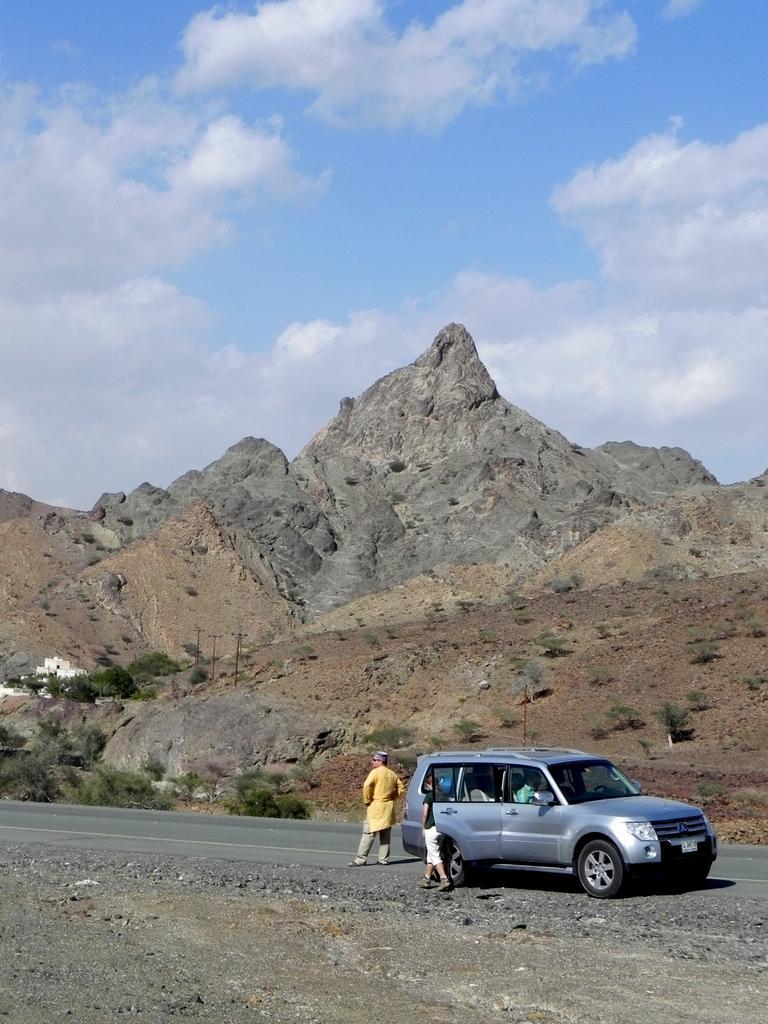How would you summarize this image in a sentence or two? At the bottom of the image there is a road and we can see a car on the road. There are people sitting in the car. In the center we can see people standing. In the background there are hills. At the top there is sky. 